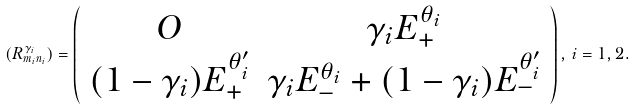Convert formula to latex. <formula><loc_0><loc_0><loc_500><loc_500>( R ^ { \gamma _ { i } } _ { m _ { i } n _ { i } } ) = \left ( \begin{array} { c c } O & \gamma _ { i } E ^ { \theta _ { i } } _ { + } \\ ( 1 - \gamma _ { i } ) E ^ { \theta ^ { \prime } _ { i } } _ { + } & \gamma _ { i } E ^ { \theta _ { i } } _ { - } + ( 1 - \gamma _ { i } ) E ^ { \theta ^ { \prime } _ { i } } _ { - } \end{array} \right ) , \, i = 1 , 2 .</formula> 